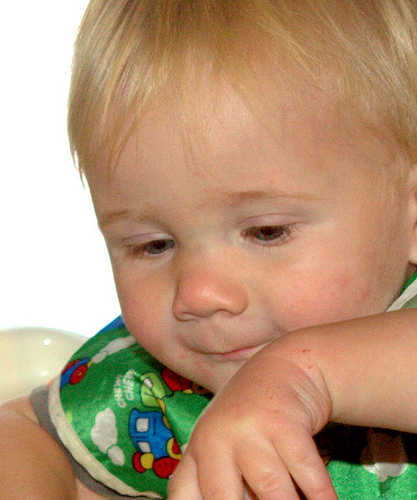<image>
Is the baby to the right of the wall? No. The baby is not to the right of the wall. The horizontal positioning shows a different relationship. 